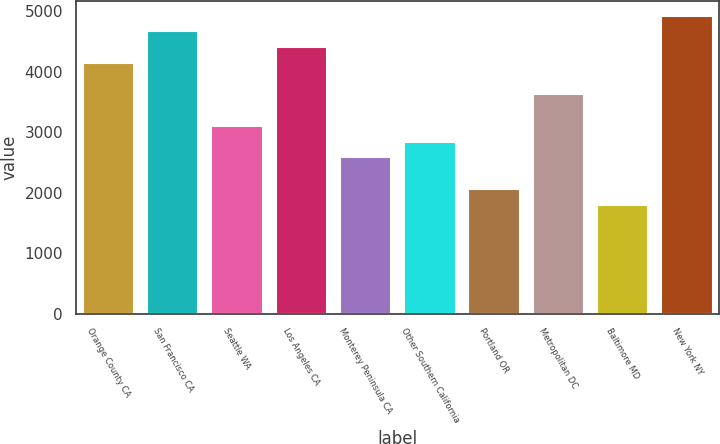Convert chart. <chart><loc_0><loc_0><loc_500><loc_500><bar_chart><fcel>Orange County CA<fcel>San Francisco CA<fcel>Seattle WA<fcel>Los Angeles CA<fcel>Monterey Peninsula CA<fcel>Other Southern California<fcel>Portland OR<fcel>Metropolitan DC<fcel>Baltimore MD<fcel>New York NY<nl><fcel>4147.5<fcel>4668.5<fcel>3105.5<fcel>4408<fcel>2584.5<fcel>2845<fcel>2063.5<fcel>3626.5<fcel>1803<fcel>4929<nl></chart> 